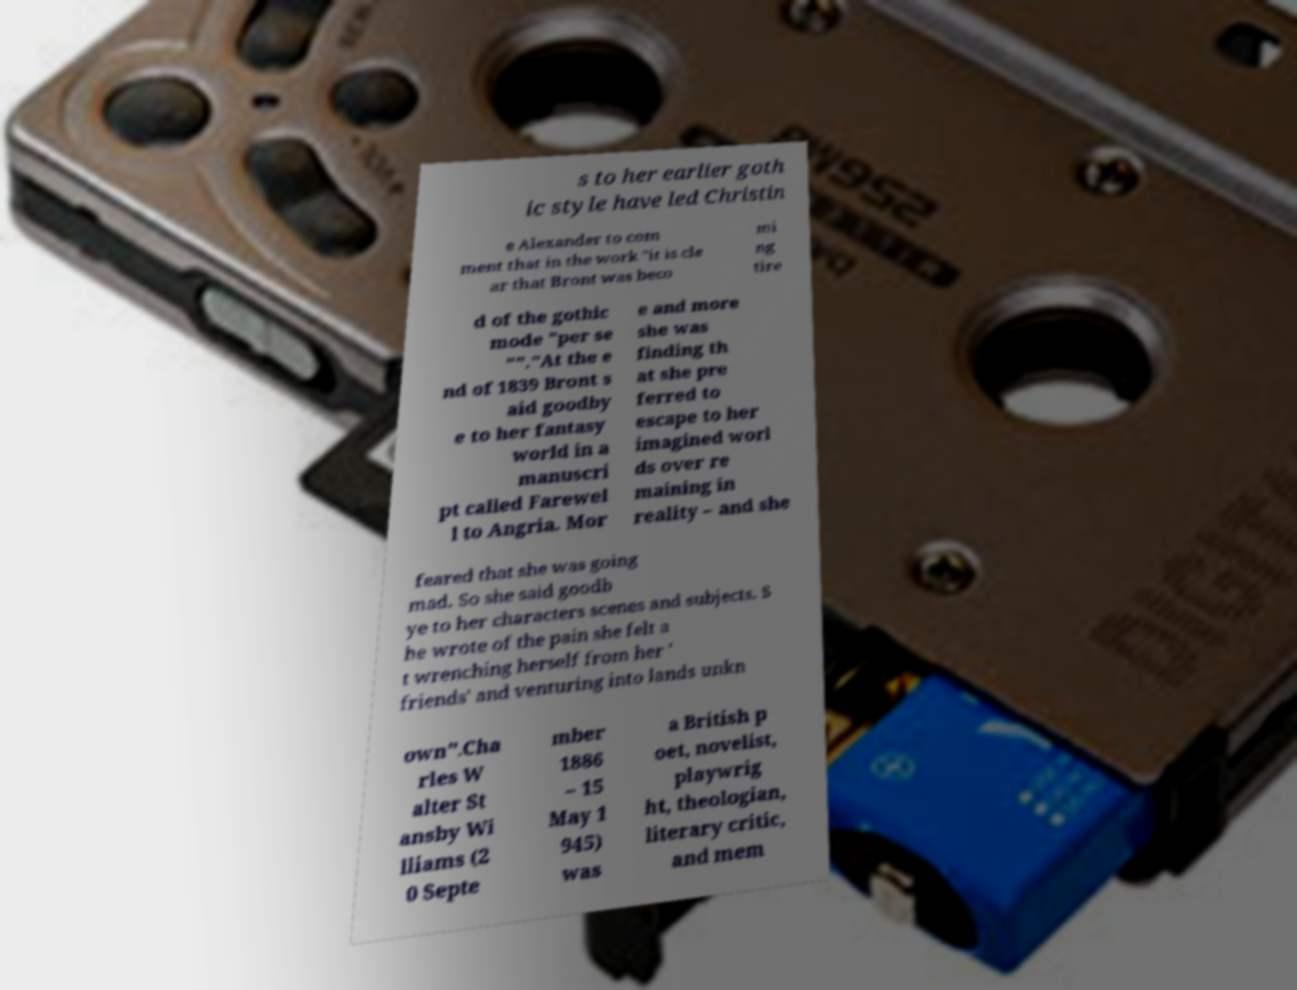What messages or text are displayed in this image? I need them in a readable, typed format. s to her earlier goth ic style have led Christin e Alexander to com ment that in the work "it is cle ar that Bront was beco mi ng tire d of the gothic mode "per se ""."At the e nd of 1839 Bront s aid goodby e to her fantasy world in a manuscri pt called Farewel l to Angria. Mor e and more she was finding th at she pre ferred to escape to her imagined worl ds over re maining in reality – and she feared that she was going mad. So she said goodb ye to her characters scenes and subjects. S he wrote of the pain she felt a t wrenching herself from her ' friends' and venturing into lands unkn own".Cha rles W alter St ansby Wi lliams (2 0 Septe mber 1886 – 15 May 1 945) was a British p oet, novelist, playwrig ht, theologian, literary critic, and mem 